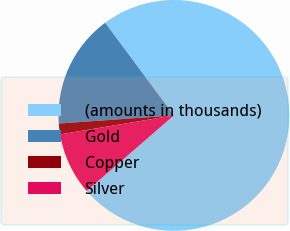<chart> <loc_0><loc_0><loc_500><loc_500><pie_chart><fcel>(amounts in thousands)<fcel>Gold<fcel>Copper<fcel>Silver<nl><fcel>73.8%<fcel>15.96%<fcel>1.51%<fcel>8.73%<nl></chart> 